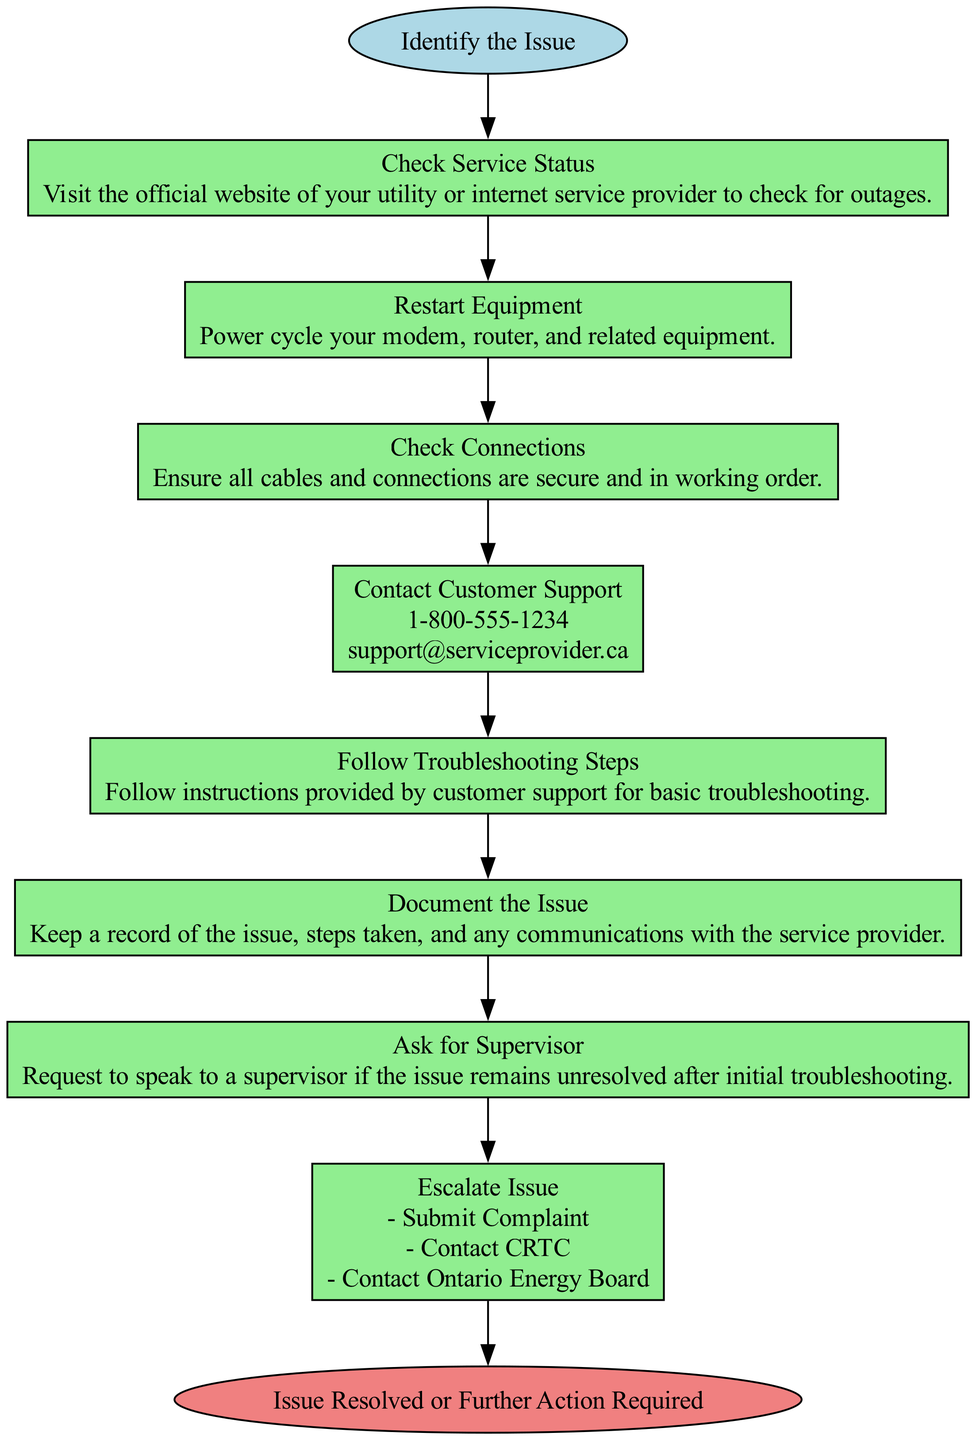What is the starting point of the process? The diagram indicates that the starting point of the process is labeled as "Identify the Issue." This is the initial step for addressing utility and internet service issues.
Answer: Identify the Issue How many steps are there in the process? By examining the steps listed in the diagram, I count a total of 8 distinct steps, starting from checking service status to escalation.
Answer: 8 What is the action taken after checking service status? The diagram shows that the next action after "Check Service Status" is to "Restart Equipment." This creates a clear sequential flow.
Answer: Restart Equipment What should be done if the issue remains unresolved after initial troubleshooting? The diagram specifies that if the issue is unresolved, one should "Ask for Supervisor." This step indicates the need for further assistance from higher management.
Answer: Ask for Supervisor What does the "Escalate Issue" step entail? The "Escalate Issue" step includes submitting a complaint and contacting regulatory bodies for unresolved issues. This indicates a deeper engagement with the problem when initial measures fail.
Answer: Submit Complaint, Contact CRTC, Contact Ontario Energy Board What information is provided for contacting customer support? The diagram includes a phone number, email, and a live chat URL under the "Contact Customer Support" step, ensuring multiple options for reaching support.
Answer: 1-800-555-1234, support@serviceprovider.ca, https://serviceprovider.ca/support/chat What is the final node of the flowchart? The diagram concludes with the node labeled "Issue Resolved or Further Action Required." This signifies that the process ends depending on the outcome of the previous steps.
Answer: Issue Resolved or Further Action Required What does the "Document the Issue" step involve? The "Document the Issue" step requires maintaining a record of the issue, steps taken, and communications with the service provider, indicating the importance of having a history for later reference.
Answer: Keep a record of the issue What must be done before contacting customer support? Before reaching out to customer support, one must complete the “Follow Troubleshooting Steps” as instructed by a support representative, indicating the necessity of previous troubleshooting to aid the process.
Answer: Follow Troubleshooting Steps 